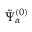<formula> <loc_0><loc_0><loc_500><loc_500>\tilde { \Psi } _ { \alpha } ^ { ( 0 ) }</formula> 